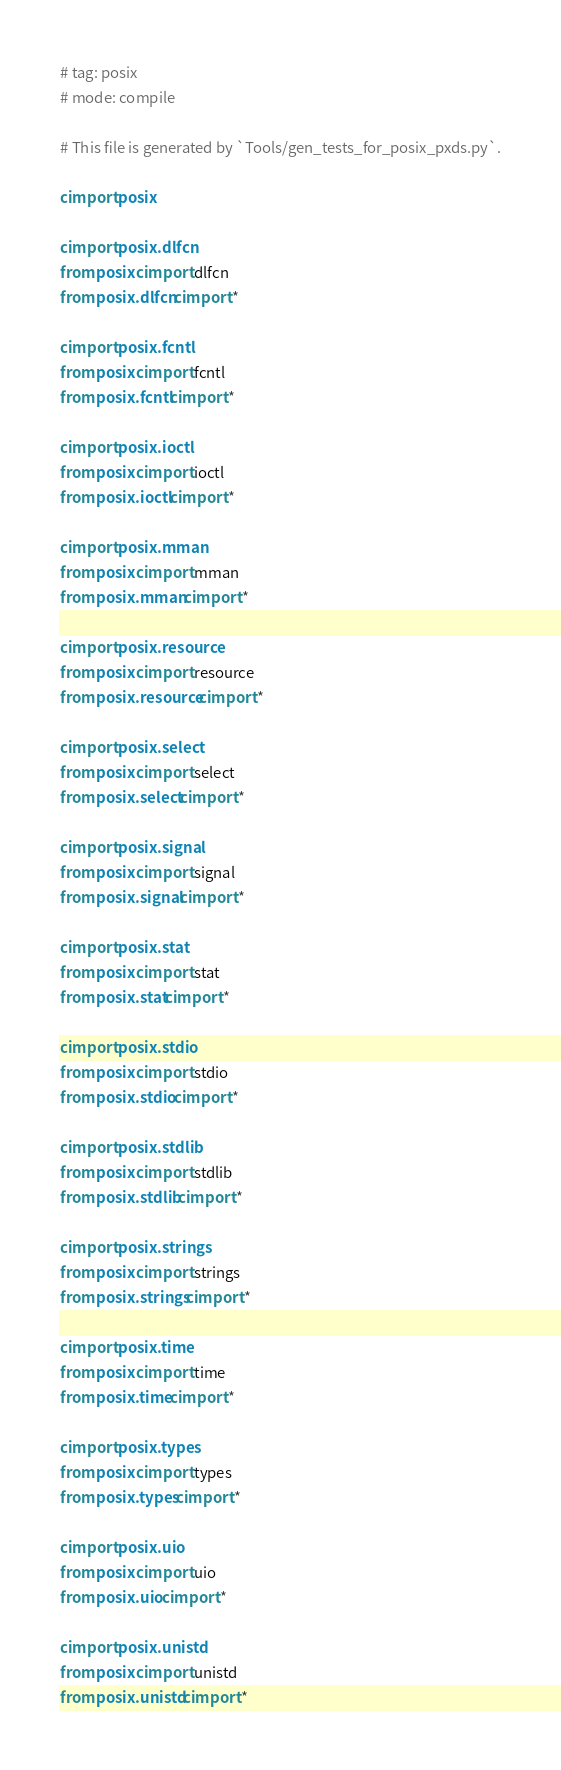Convert code to text. <code><loc_0><loc_0><loc_500><loc_500><_Cython_># tag: posix
# mode: compile

# This file is generated by `Tools/gen_tests_for_posix_pxds.py`.

cimport posix

cimport posix.dlfcn
from posix cimport dlfcn
from posix.dlfcn cimport *

cimport posix.fcntl
from posix cimport fcntl
from posix.fcntl cimport *

cimport posix.ioctl
from posix cimport ioctl
from posix.ioctl cimport *

cimport posix.mman
from posix cimport mman
from posix.mman cimport *

cimport posix.resource
from posix cimport resource
from posix.resource cimport *

cimport posix.select
from posix cimport select
from posix.select cimport *

cimport posix.signal
from posix cimport signal
from posix.signal cimport *

cimport posix.stat
from posix cimport stat
from posix.stat cimport *

cimport posix.stdio
from posix cimport stdio
from posix.stdio cimport *

cimport posix.stdlib
from posix cimport stdlib
from posix.stdlib cimport *

cimport posix.strings
from posix cimport strings
from posix.strings cimport *

cimport posix.time
from posix cimport time
from posix.time cimport *

cimport posix.types
from posix cimport types
from posix.types cimport *

cimport posix.uio
from posix cimport uio
from posix.uio cimport *

cimport posix.unistd
from posix cimport unistd
from posix.unistd cimport *
</code> 